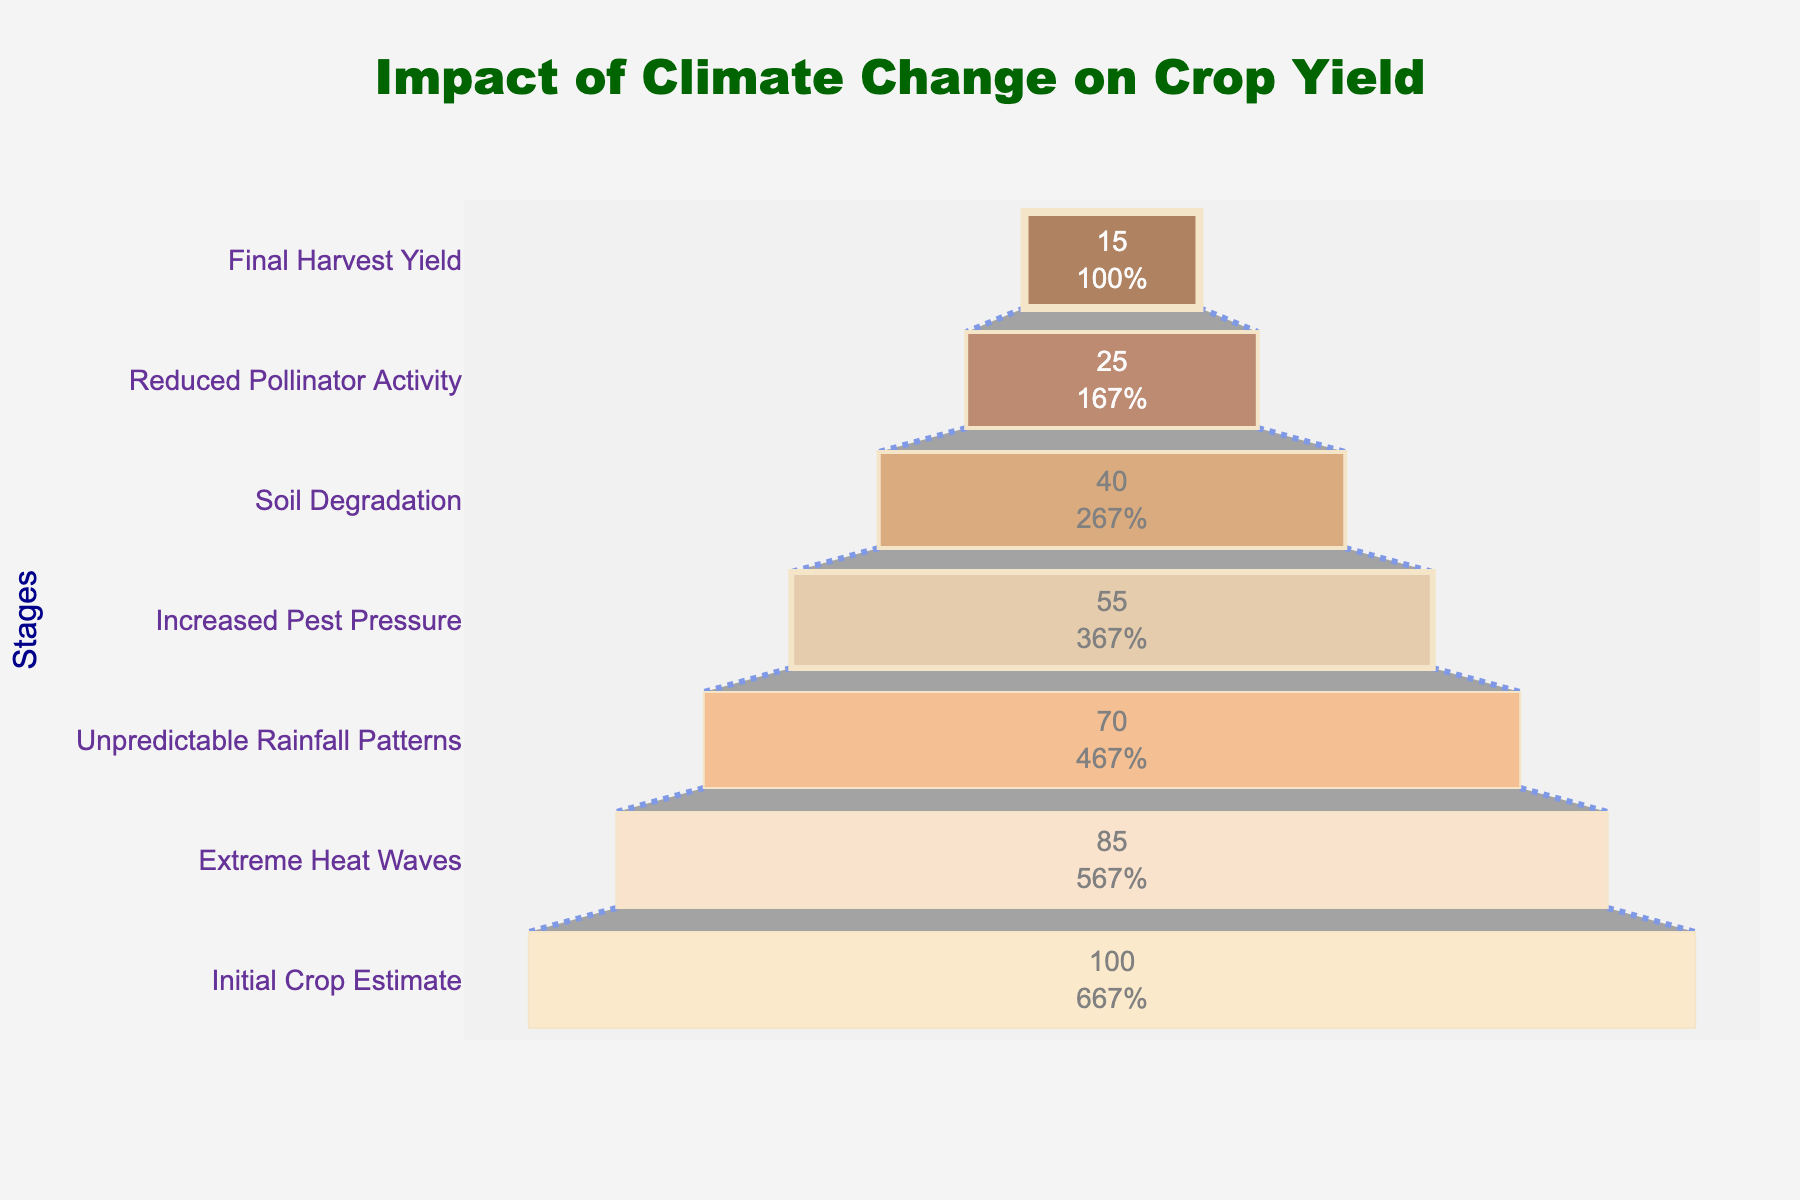What is the title of the funnel chart? The title of the funnel chart is prominently displayed at the top of the figure. It reads "Impact of Climate Change on Crop Yield".
Answer: Impact of Climate Change on Crop Yield How many stages are there in total in this funnel chart? By counting all the different stages listed along the y-axis, we see there are seven stages in total.
Answer: Seven Which stage shows the largest reduction in crop yield? The x-axis values represent the yield reduction percentages. By checking the values, "Extreme Heat Waves" shows the largest reduction of the second largest bar, with a yield reduction of 85%.
Answer: Extreme Heat Waves Compare the yield reduction caused by "Increased Pest Pressure" and "Soil Degradation." Which one is higher and by how much? When looking at the x-axis values, "Increased Pest Pressure" has a yield reduction of 55%, and "Soil Degradation" has 40%. The difference is 55% - 40% = 15%.
Answer: Increased Pest Pressure, by 15% What is the percentage yield reduction at the final stage? At the bottom of the funnel, labeled as "Final Harvest Yield," the yield reduction is listed as 15%.
Answer: 15% Which stage contributes to the reduction of crop yield by exactly 30% from the previous stage? By subtracting the yield reduction values stage by stage, "Increased Pest Pressure" at 55% minus "Soil Degradation" at 40% results in a 30% reduction.
Answer: Soil Degradation What percentage of the crop yield is estimated to be lost overall, from the initial estimate to the final harvest yield? The initial crop yield estimate is 100%, and the final harvest yield is 15%, resulting in a total loss of 100% - 15% = 85%.
Answer: 85% What stage becomes the midpoint in terms of the total number of stages? The midpoint of the seven stages is the fourth one when listed: "Increased Pest Pressure". This is found by calculating the midpoint index (7 + 1) / 2 = 4.
Answer: Increased Pest Pressure Compare the yield reductions caused by "Extreme Heat Waves" and "Reduced Pollinator Activity." Which one has a greater impact and by how much? The yield reduction for "Extreme Heat Waves" is 85%, while for "Reduced Pollinator Activity" it is 25%. The difference is 85% - 25% = 60%.
Answer: Extreme Heat Waves, by 60% Which color represents the stage with the least impact on yield reduction, and what is the yield reduction percentage for that stage? The smallest bar on the funnel which represents the "Final Harvest Yield" stage is in the lightest color (#FFE4B5) and indicates a 15% yield reduction.
Answer: Lightest color (#FFE4B5), 15% 